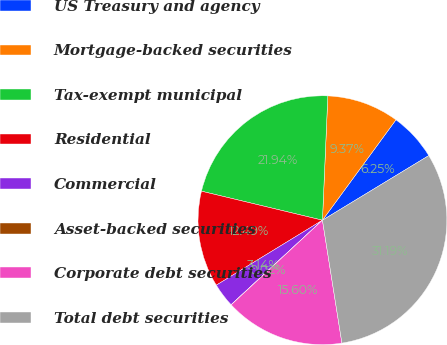Convert chart to OTSL. <chart><loc_0><loc_0><loc_500><loc_500><pie_chart><fcel>US Treasury and agency<fcel>Mortgage-backed securities<fcel>Tax-exempt municipal<fcel>Residential<fcel>Commercial<fcel>Asset-backed securities<fcel>Corporate debt securities<fcel>Total debt securities<nl><fcel>6.25%<fcel>9.37%<fcel>21.94%<fcel>12.49%<fcel>3.14%<fcel>0.02%<fcel>15.6%<fcel>31.19%<nl></chart> 